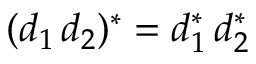Convert formula to latex. <formula><loc_0><loc_0><loc_500><loc_500>( d _ { 1 } \, d _ { 2 } ) ^ { * } = d _ { 1 } ^ { * } \, d _ { 2 } ^ { * }</formula> 